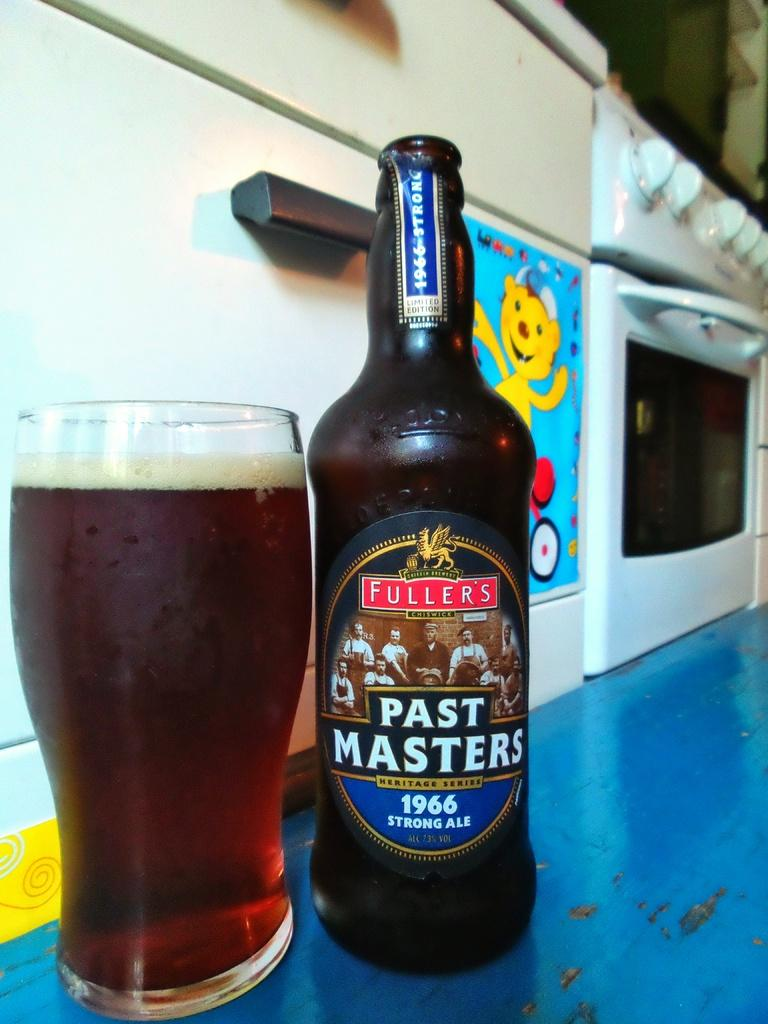Provide a one-sentence caption for the provided image. A glass of beer sits next to the bottle, which is labelled Past Masters. 